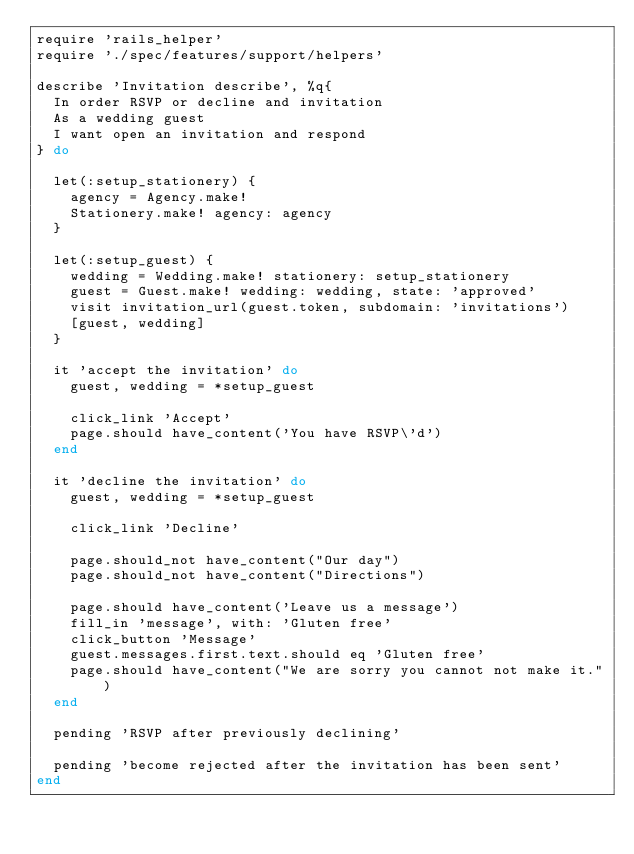Convert code to text. <code><loc_0><loc_0><loc_500><loc_500><_Ruby_>require 'rails_helper'
require './spec/features/support/helpers'

describe 'Invitation describe', %q{
  In order RSVP or decline and invitation
  As a wedding guest
  I want open an invitation and respond
} do

  let(:setup_stationery) {
    agency = Agency.make!
    Stationery.make! agency: agency
  }

  let(:setup_guest) {
    wedding = Wedding.make! stationery: setup_stationery
    guest = Guest.make! wedding: wedding, state: 'approved'
    visit invitation_url(guest.token, subdomain: 'invitations')
    [guest, wedding]
  }

  it 'accept the invitation' do
    guest, wedding = *setup_guest

    click_link 'Accept'
    page.should have_content('You have RSVP\'d')
  end

  it 'decline the invitation' do
    guest, wedding = *setup_guest

    click_link 'Decline'

    page.should_not have_content("Our day")
    page.should_not have_content("Directions")

    page.should have_content('Leave us a message')
    fill_in 'message', with: 'Gluten free'
    click_button 'Message'
    guest.messages.first.text.should eq 'Gluten free'
    page.should have_content("We are sorry you cannot not make it.")
  end

  pending 'RSVP after previously declining'

  pending 'become rejected after the invitation has been sent'
end
</code> 